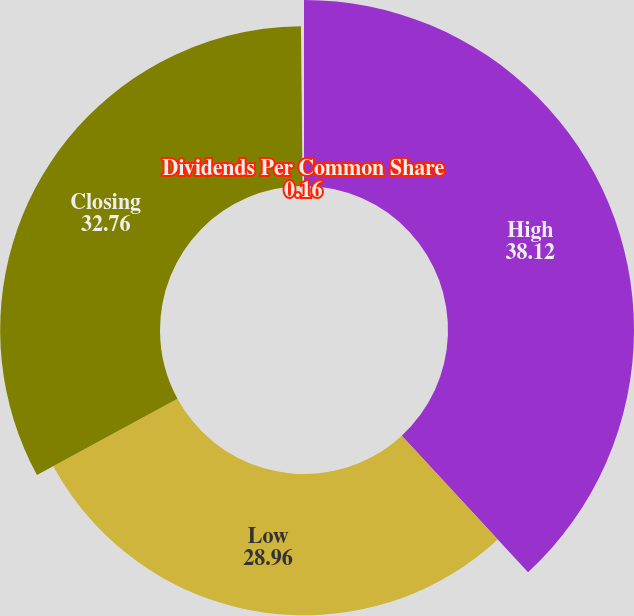Convert chart to OTSL. <chart><loc_0><loc_0><loc_500><loc_500><pie_chart><fcel>High<fcel>Low<fcel>Closing<fcel>Dividends Per Common Share<nl><fcel>38.12%<fcel>28.96%<fcel>32.76%<fcel>0.16%<nl></chart> 